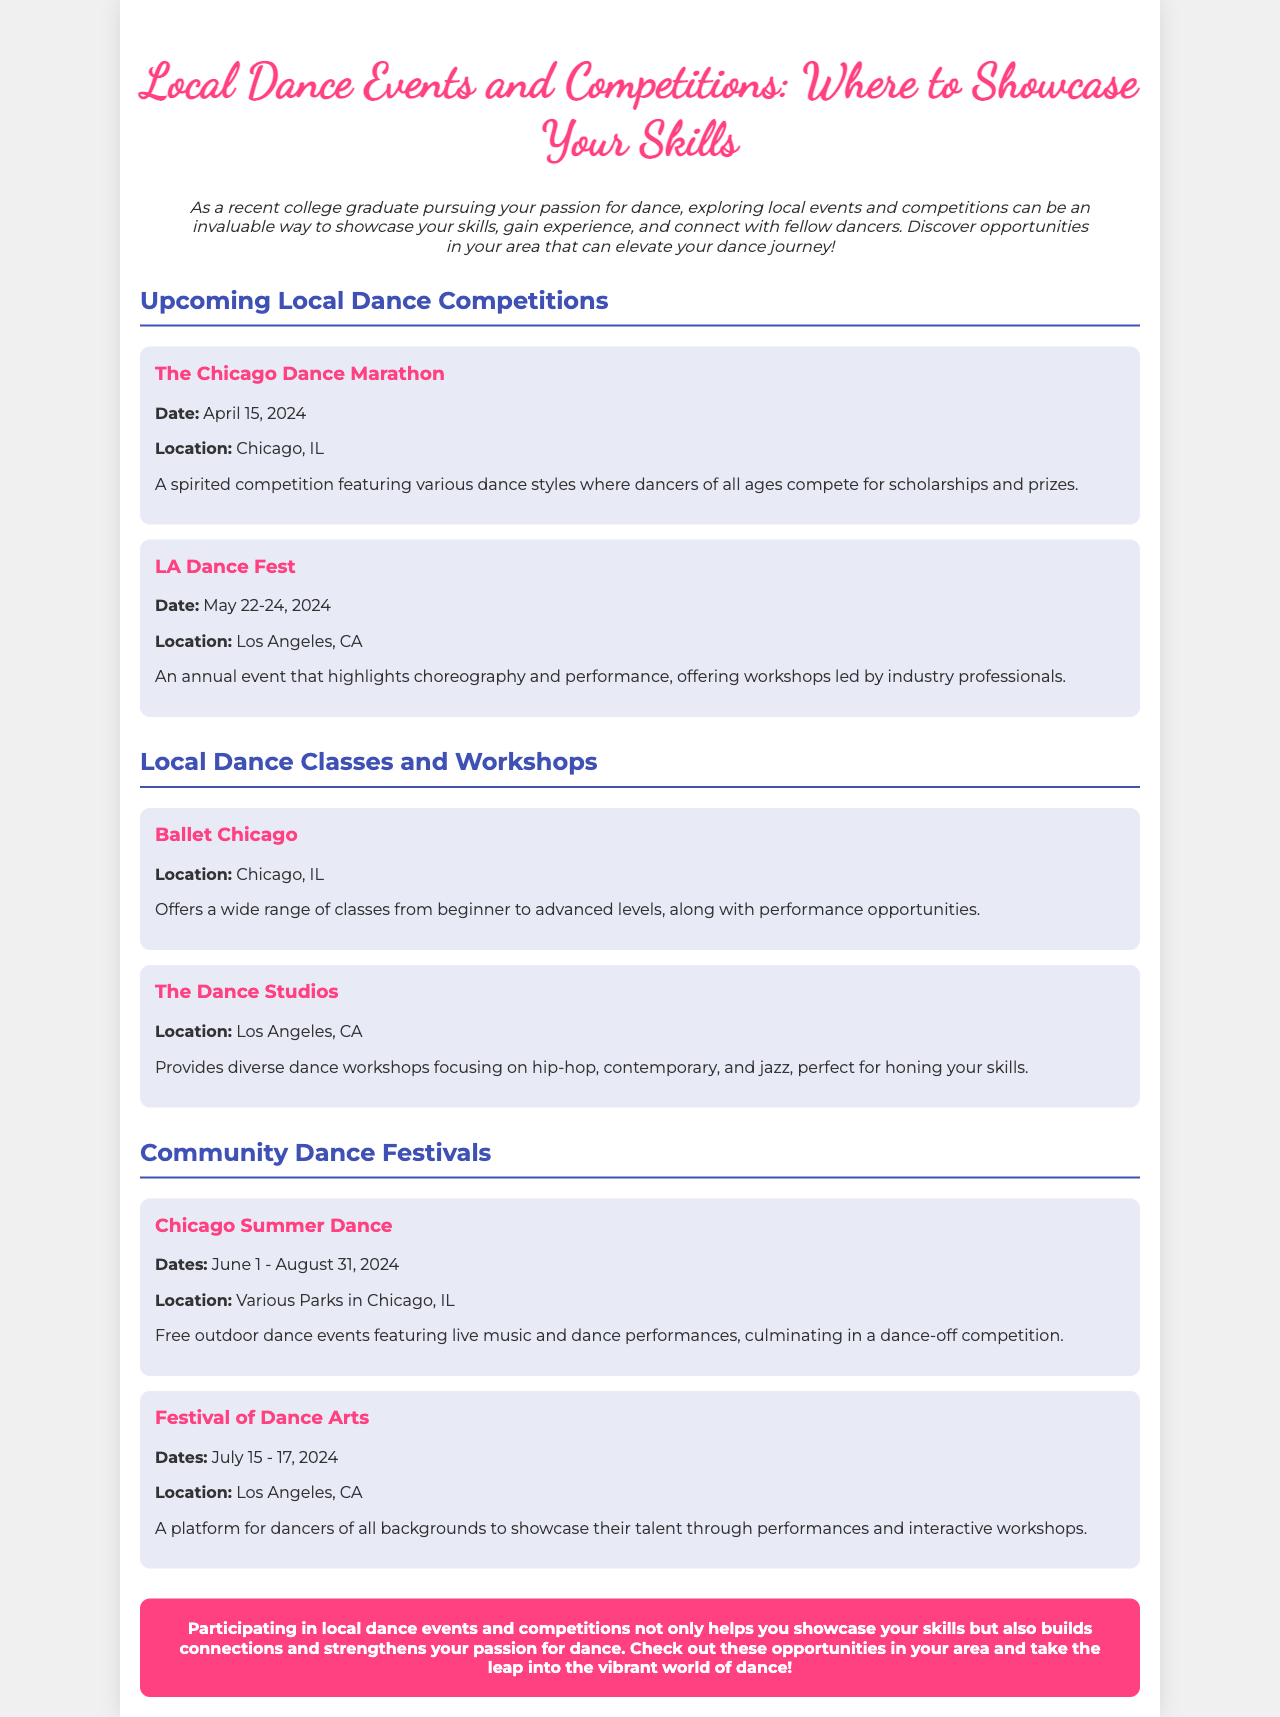What is the date of The Chicago Dance Marathon? The document specifies that The Chicago Dance Marathon will take place on April 15, 2024.
Answer: April 15, 2024 Where is the LA Dance Fest held? According to the document, the LA Dance Fest is located in Los Angeles, CA.
Answer: Los Angeles, CA What type of dance classes does Ballet Chicago offer? The document mentions that Ballet Chicago provides a wide range of classes from beginner to advanced levels.
Answer: Beginner to advanced levels What are the dates for the Chicago Summer Dance? The document states that Chicago Summer Dance runs from June 1 to August 31, 2024.
Answer: June 1 - August 31, 2024 What festival offers interactive workshops in Los Angeles? The document highlights the Festival of Dance Arts as a platform offering interactive workshops.
Answer: Festival of Dance Arts How many dance events are listed under upcoming competitions? The document lists two dance events under upcoming competitions: The Chicago Dance Marathon and LA Dance Fest.
Answer: Two What is the primary focus of The Dance Studios? The document indicates that The Dance Studios focuses on hip-hop, contemporary, and jazz dance workshops.
Answer: Hip-hop, contemporary, and jazz What is the concluding thought of the brochure? The conclusion emphasizes the importance of participating in local dance events for skill showcasing and community building.
Answer: Showcase skills and build connections How does the document categorize local dance opportunities? The document categorizes local dance opportunities into competitions, classes and workshops, and festivals.
Answer: Competitions, classes and workshops, and festivals 